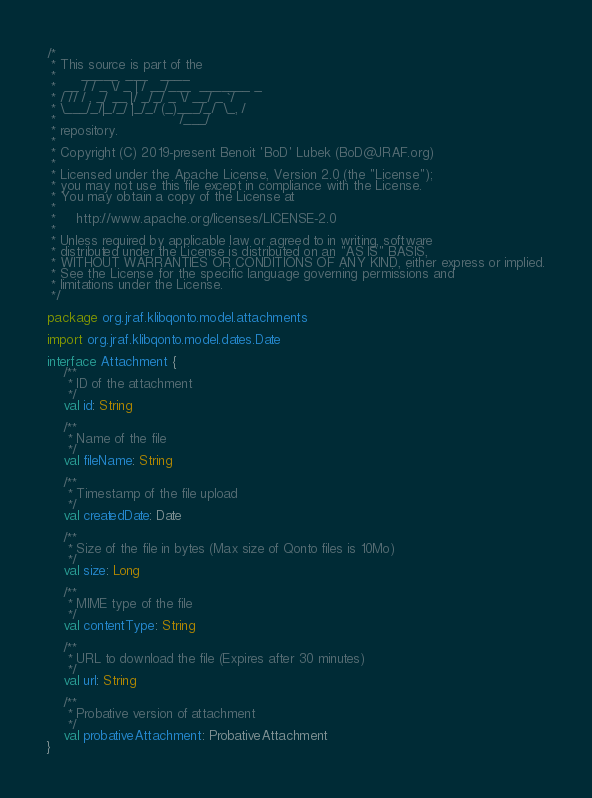<code> <loc_0><loc_0><loc_500><loc_500><_Kotlin_>/*
 * This source is part of the
 *      _____  ___   ____
 *  __ / / _ \/ _ | / __/___  _______ _
 * / // / , _/ __ |/ _/_/ _ \/ __/ _ `/
 * \___/_/|_/_/ |_/_/ (_)___/_/  \_, /
 *                              /___/
 * repository.
 *
 * Copyright (C) 2019-present Benoit 'BoD' Lubek (BoD@JRAF.org)
 *
 * Licensed under the Apache License, Version 2.0 (the "License");
 * you may not use this file except in compliance with the License.
 * You may obtain a copy of the License at
 *
 *     http://www.apache.org/licenses/LICENSE-2.0
 *
 * Unless required by applicable law or agreed to in writing, software
 * distributed under the License is distributed on an "AS IS" BASIS,
 * WITHOUT WARRANTIES OR CONDITIONS OF ANY KIND, either express or implied.
 * See the License for the specific language governing permissions and
 * limitations under the License.
 */

package org.jraf.klibqonto.model.attachments

import org.jraf.klibqonto.model.dates.Date

interface Attachment {
    /**
     * ID of the attachment
     */
    val id: String

    /**
     * Name of the file
     */
    val fileName: String

    /**
     * Timestamp of the file upload
     */
    val createdDate: Date

    /**
     * Size of the file in bytes (Max size of Qonto files is 10Mo)
     */
    val size: Long

    /**
     * MIME type of the file
     */
    val contentType: String

    /**
     * URL to download the file (Expires after 30 minutes)
     */
    val url: String

    /**
     * Probative version of attachment
     */
    val probativeAttachment: ProbativeAttachment
}
</code> 